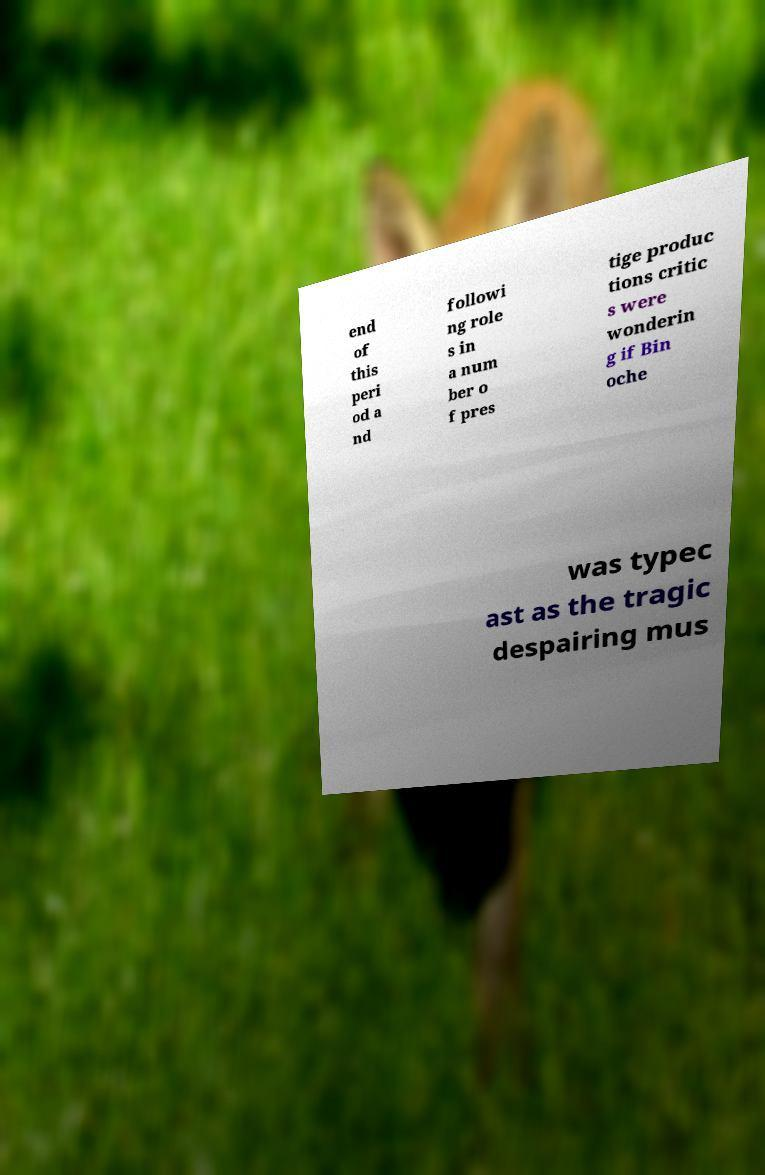Please identify and transcribe the text found in this image. end of this peri od a nd followi ng role s in a num ber o f pres tige produc tions critic s were wonderin g if Bin oche was typec ast as the tragic despairing mus 